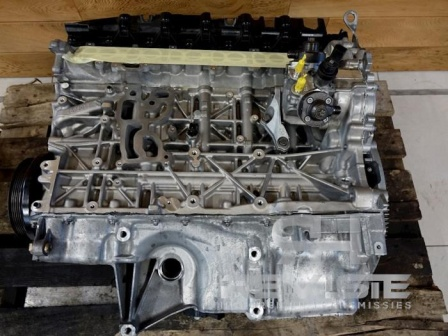If this engine could talk, what stories might it tell? If this engine could talk, it might share tales of long road trips across vast landscapes, enduring both the tranquility of countryside drives and the hustle-bustle of city traffic. It might recall the thrill of accelerating on open highways, the dependable reliability during daily commutes, and perhaps even the challenges of running in harsh conditions. It could recount the meticulous care it received during maintenance visits or the moments of strain where it pushed to its limits, ensuring the safety and convenience of its passengers. This engine holds memories of every mile it powered, every turn of the ignition, and the dedication it put into every journey. 